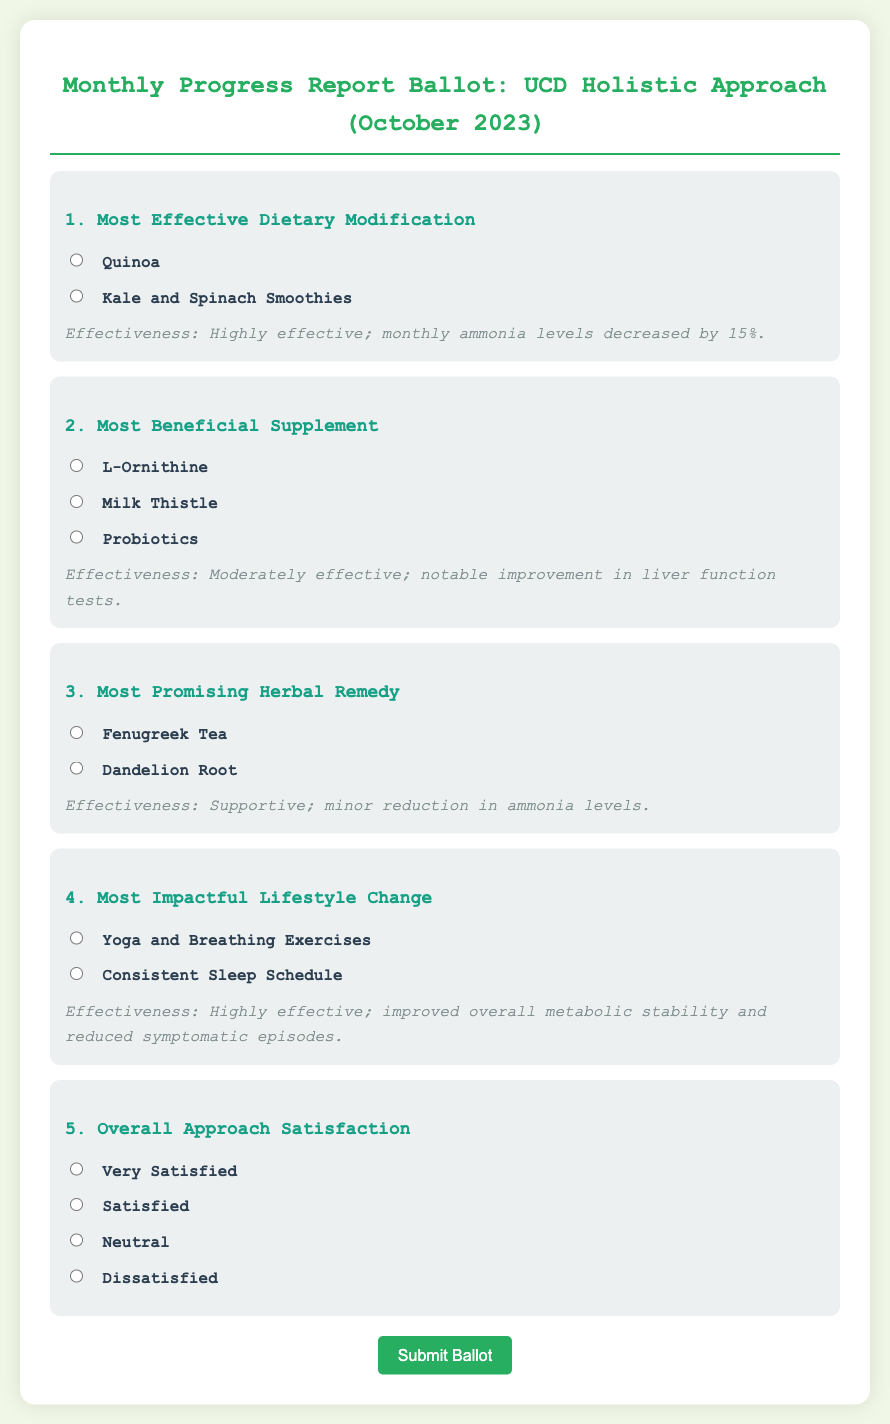What is the date of the progress report? The date of the progress report is mentioned in the title of the document.
Answer: October 2023 What dietary modification was noted as most effective? The document highlights one dietary change as particularly effective, found in the first ballot item.
Answer: Quinoa What was the effectiveness rating for the supplement "Probiotics"? The effectiveness information is stated alongside each supplement option in the document.
Answer: Moderately effective Which lifestyle change was reported as most impactful? The document specifies the most impactful lifestyle change in the corresponding ballot item.
Answer: Yoga and Breathing Exercises What type of herbal remedy is mentioned as supportive? The document includes information about the effectiveness of herbal remedies, specifically noting one as supportive.
Answer: Fenugreek Tea How many options are provided for the overall approach satisfaction? The document outlines the categories available for satisfaction, which is indicated in the last ballot item.
Answer: Four options Which supplement showed a notable improvement in liver function tests? The effectiveness descriptions provide insight into which supplement had a noticeable impact on liver functions.
Answer: Milk Thistle What percentage decrease in ammonia levels was noted from the dietary modification? The document specifies the effectiveness of dietary modifications, including the decrease in ammonia levels.
Answer: 15% 